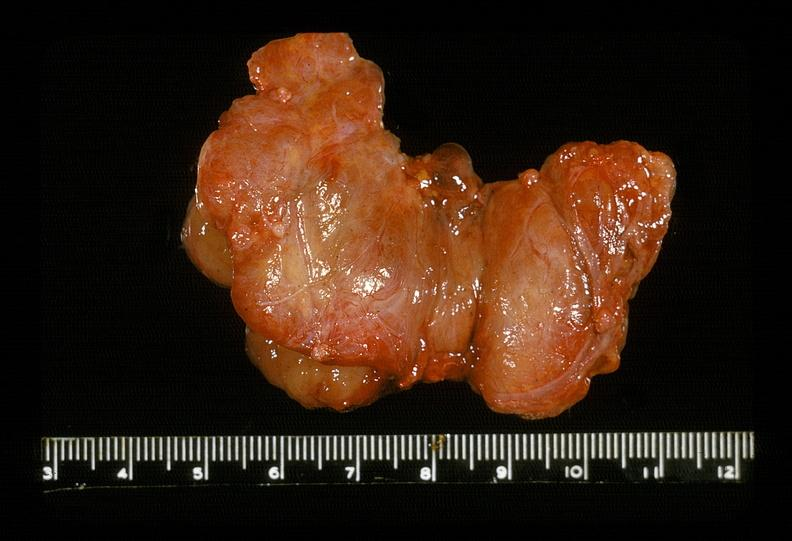where does this belong to?
Answer the question using a single word or phrase. Endocrine system 